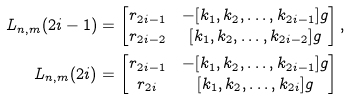<formula> <loc_0><loc_0><loc_500><loc_500>L _ { n , m } ( 2 i - 1 ) & = \begin{bmatrix} r _ { 2 i - 1 } & - [ k _ { 1 } , k _ { 2 } , \dots , k _ { 2 i - 1 } ] g \\ r _ { 2 i - 2 } & [ k _ { 1 } , k _ { 2 } , \dots , k _ { 2 i - 2 } ] g \end{bmatrix} , \\ L _ { n , m } ( 2 i ) & = \begin{bmatrix} r _ { 2 i - 1 } & - [ k _ { 1 } , k _ { 2 } , \dots , k _ { 2 i - 1 } ] g \\ r _ { 2 i } & [ k _ { 1 } , k _ { 2 } , \dots , k _ { 2 i } ] g \end{bmatrix}</formula> 